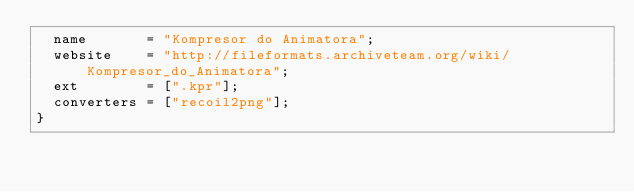<code> <loc_0><loc_0><loc_500><loc_500><_JavaScript_>	name       = "Kompresor do Animatora";
	website    = "http://fileformats.archiveteam.org/wiki/Kompresor_do_Animatora";
	ext        = [".kpr"];
	converters = ["recoil2png"];
}
</code> 